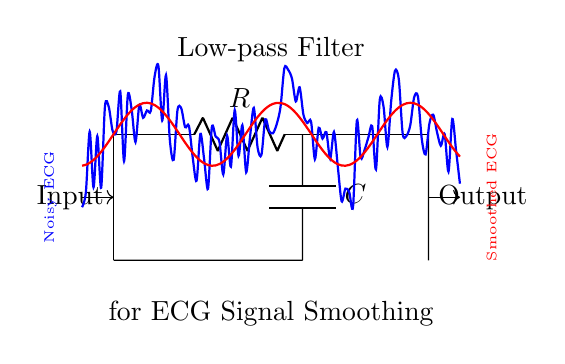What type of filter is represented in the diagram? The diagram shows a low-pass filter, indicated by the label and the arrangement of components in the circuit. The configuration of the resistor and capacitor allows low-frequency signals to pass while attenuating high-frequency signals.
Answer: Low-pass filter What components are used in this circuit? The circuit uses a resistor (R) and a capacitor (C), which are standard components for constructing a low-pass filter. They are specifically arranged to provide the desired filtering effect on the ECG signals.
Answer: Resistor and capacitor What is the purpose of this low-pass filter? The purpose of the low-pass filter is to smooth the ECG signals by removing high-frequency noise, which is crucial in medical monitoring to ensure clear signal interpretation. This is explicitly mentioned in the diagram's description.
Answer: Smoothing ECG signals What is connected to the output of this filter? The output of the filter is connected to the interface that displays the smoothed ECG signal, which is represented in red on the diagram, indicating the processed output for monitoring purposes.
Answer: Smoothed ECG signal How does the arrangement of the components affect signal processing? The arrangement of the resistor and capacitor forms a specific frequency response characteristic, allowing the circuit to attenuate higher-frequency noise while retaining the integrity of lower-frequency ECG signals. This selective frequency response is fundamental to how a low-pass filter operates.
Answer: Attenuates high-frequency noise What does the "blue" curve represent in the plot? The blue curve represents the noisy ECG signal before processing by the low-pass filter, showing fluctuations that contain high-frequency interference, which the filter aims to reduce.
Answer: Noisy ECG signal What effect does this low-pass filter have on the noisy ECG signal? The low-pass filter smooths out the noisy ECG signal, as indicated by the transition from the noisy blue curve to the smoothed red curve in the plot. This allows for clearer signal interpretation in medical applications.
Answer: Reduces noise and smooths signal 